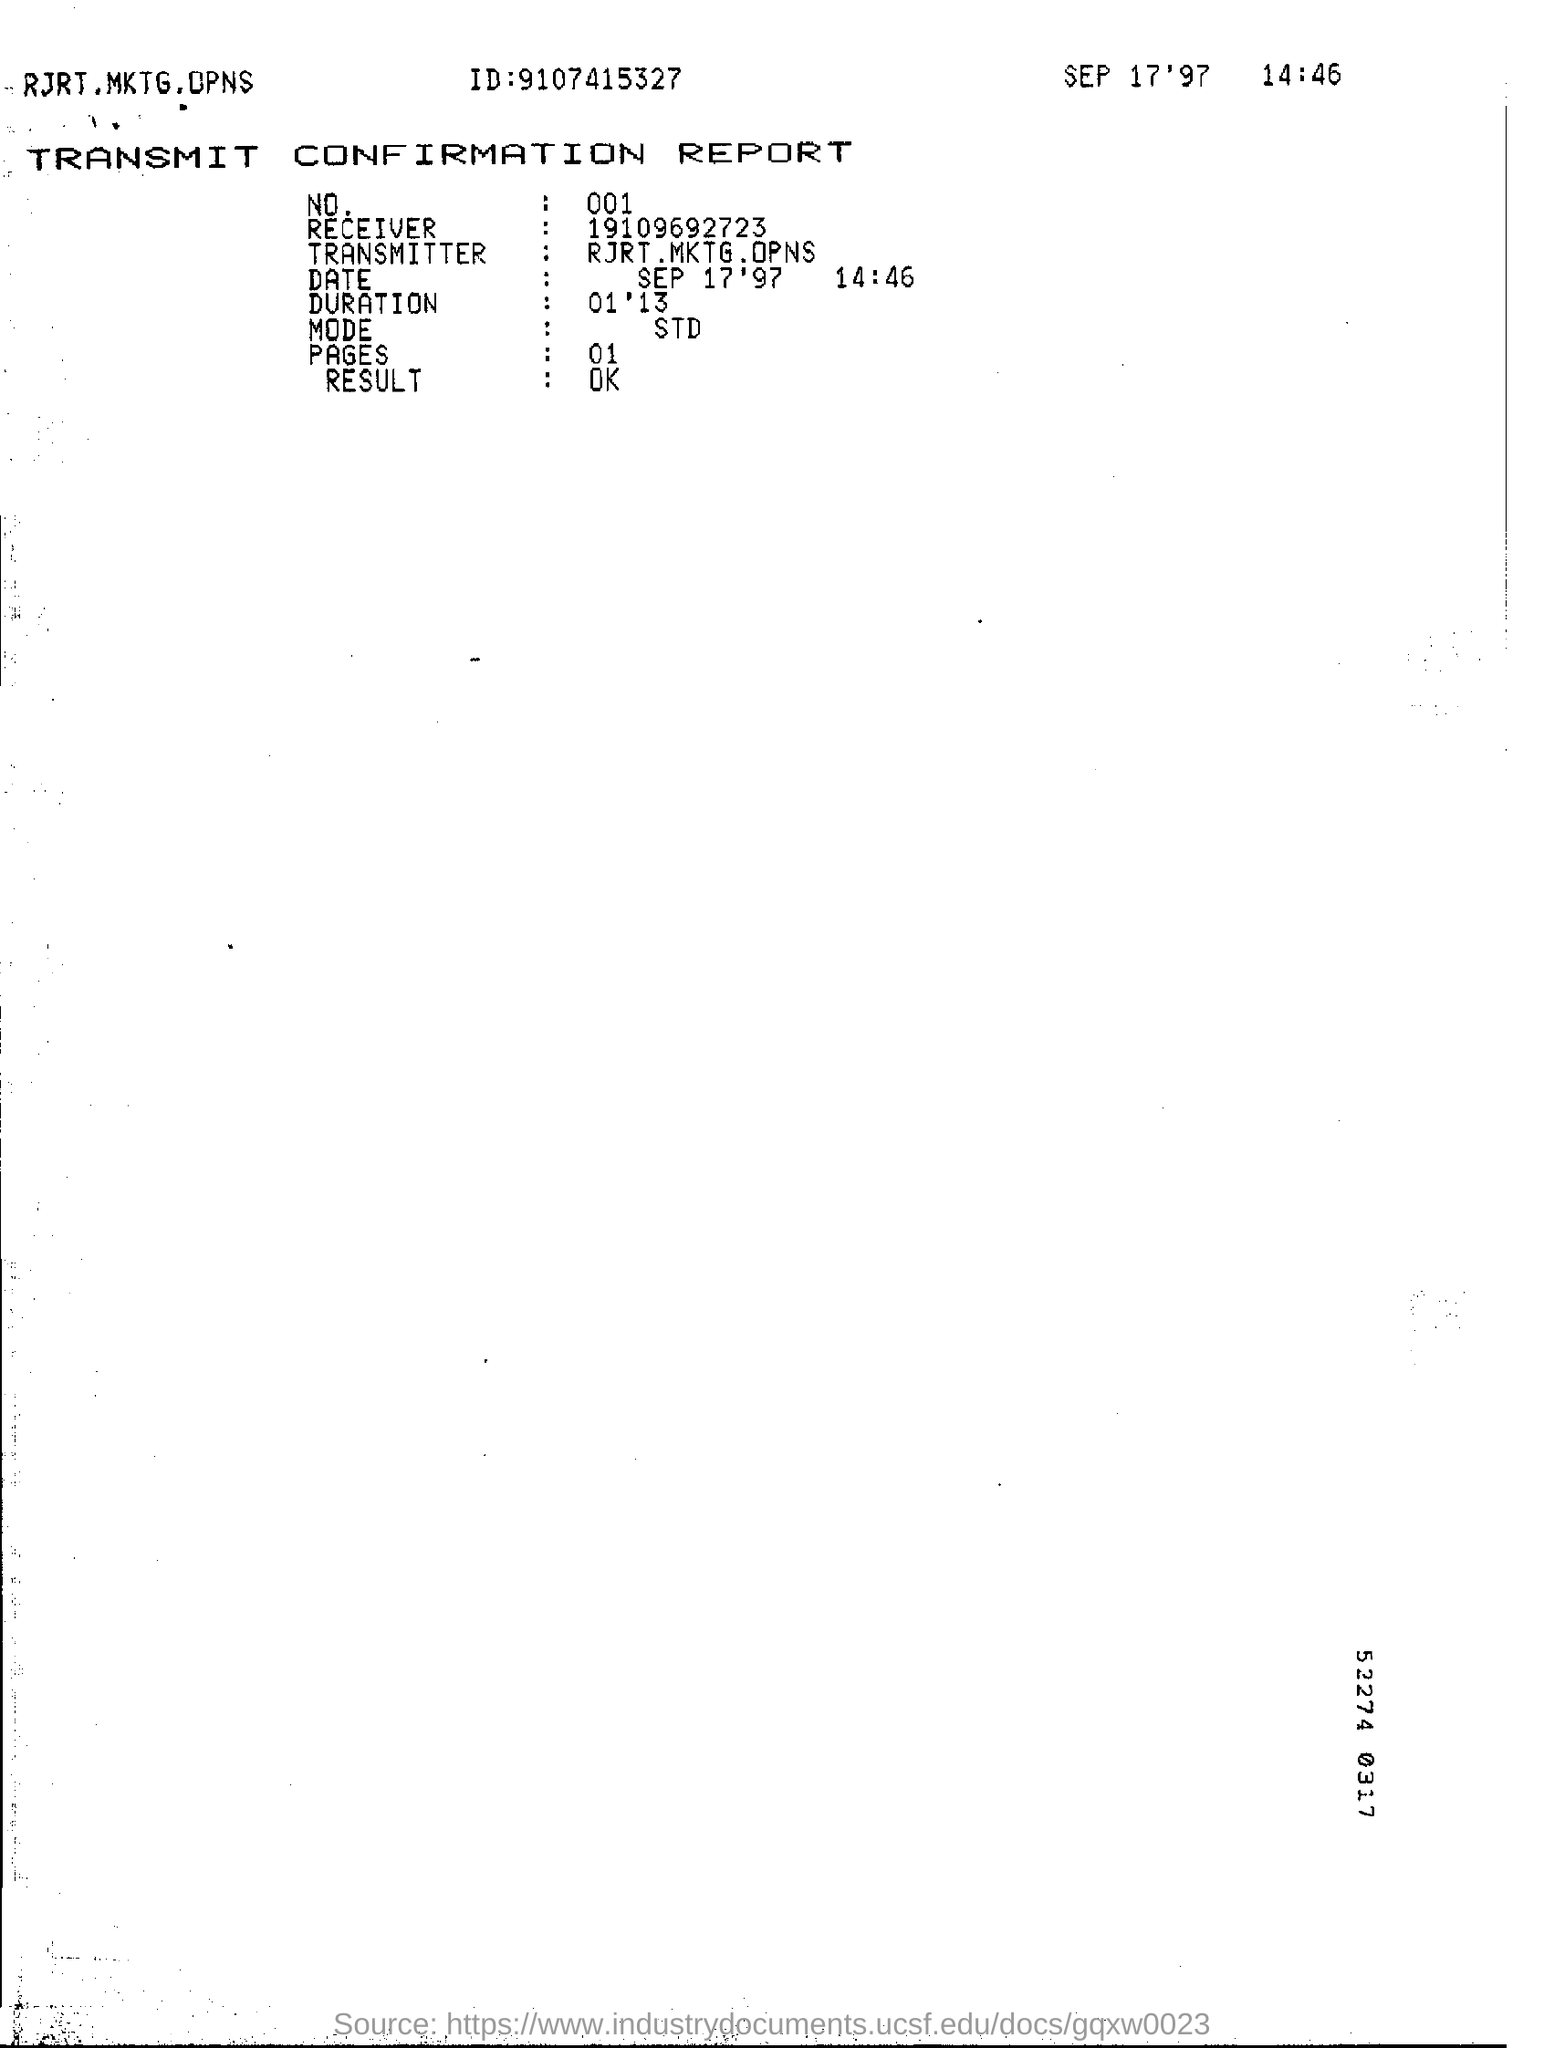Highlight a few significant elements in this photo. The Transmitter is RJRT. Marketing. Operations. The document contains a number written as "9107415327..." which serves as identification. The Receiver Number is 19109692723... The result of the document is "ok..". The date mentioned at the top of the document is September 17, 1997. 